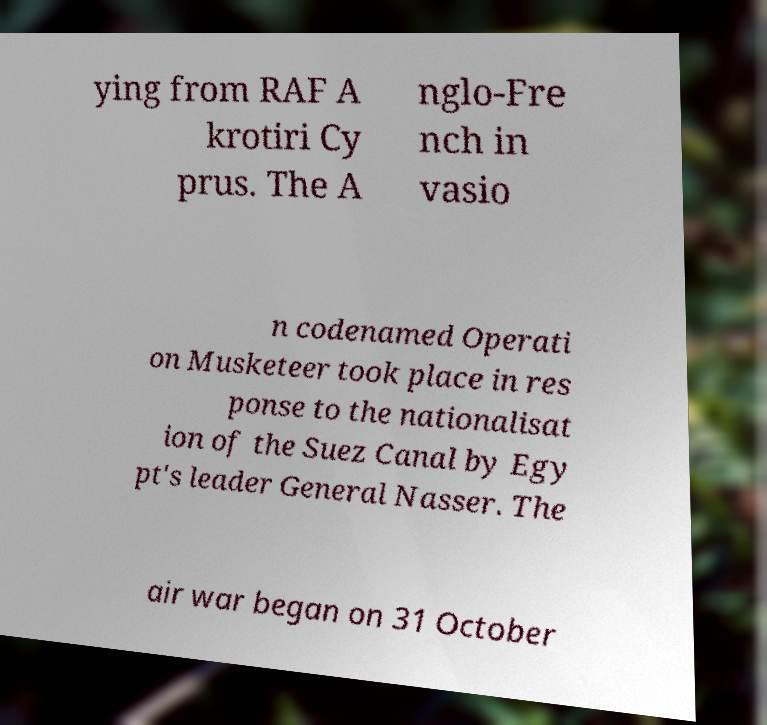Can you read and provide the text displayed in the image?This photo seems to have some interesting text. Can you extract and type it out for me? ying from RAF A krotiri Cy prus. The A nglo-Fre nch in vasio n codenamed Operati on Musketeer took place in res ponse to the nationalisat ion of the Suez Canal by Egy pt's leader General Nasser. The air war began on 31 October 